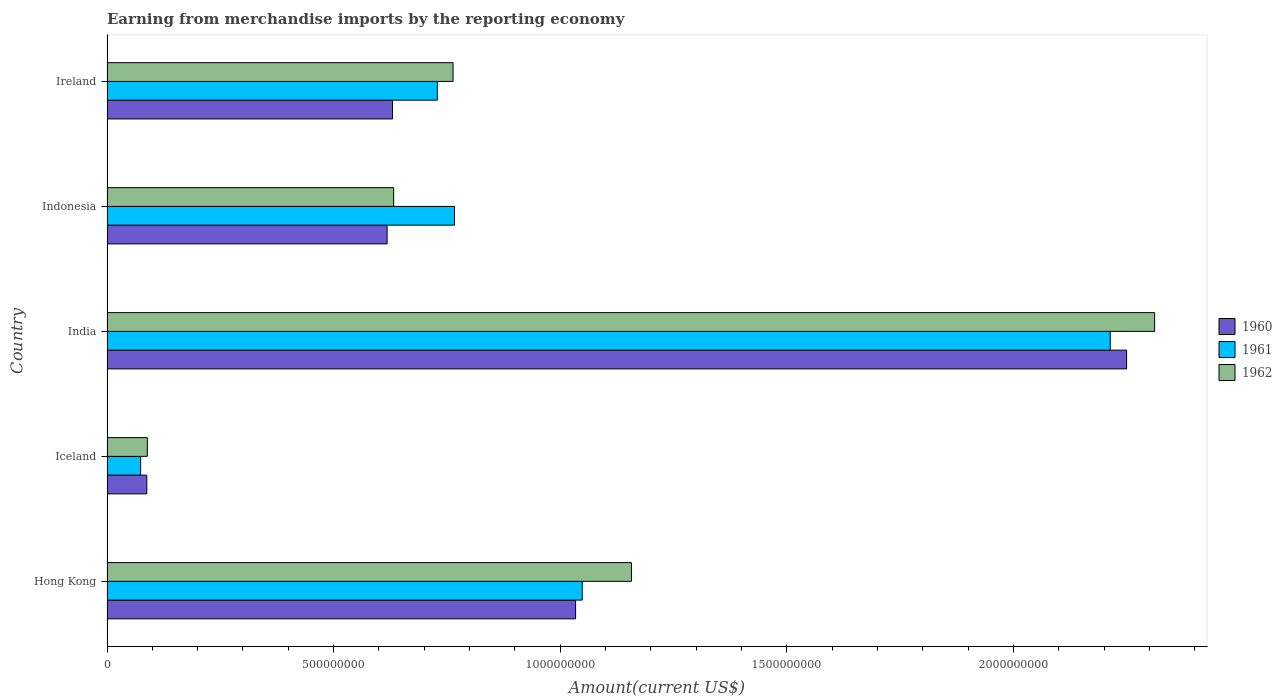How many different coloured bars are there?
Offer a terse response. 3. Are the number of bars per tick equal to the number of legend labels?
Your answer should be very brief. Yes. How many bars are there on the 4th tick from the top?
Give a very brief answer. 3. What is the label of the 4th group of bars from the top?
Keep it short and to the point. Iceland. In how many cases, is the number of bars for a given country not equal to the number of legend labels?
Ensure brevity in your answer.  0. What is the amount earned from merchandise imports in 1960 in Ireland?
Provide a short and direct response. 6.30e+08. Across all countries, what is the maximum amount earned from merchandise imports in 1961?
Offer a very short reply. 2.21e+09. Across all countries, what is the minimum amount earned from merchandise imports in 1961?
Give a very brief answer. 7.42e+07. In which country was the amount earned from merchandise imports in 1961 minimum?
Ensure brevity in your answer.  Iceland. What is the total amount earned from merchandise imports in 1961 in the graph?
Make the answer very short. 4.83e+09. What is the difference between the amount earned from merchandise imports in 1962 in Hong Kong and that in India?
Offer a very short reply. -1.15e+09. What is the difference between the amount earned from merchandise imports in 1961 in Ireland and the amount earned from merchandise imports in 1960 in Indonesia?
Ensure brevity in your answer.  1.11e+08. What is the average amount earned from merchandise imports in 1961 per country?
Your answer should be very brief. 9.66e+08. What is the difference between the amount earned from merchandise imports in 1962 and amount earned from merchandise imports in 1961 in Iceland?
Offer a terse response. 1.48e+07. In how many countries, is the amount earned from merchandise imports in 1960 greater than 1400000000 US$?
Your answer should be very brief. 1. What is the ratio of the amount earned from merchandise imports in 1961 in Hong Kong to that in Ireland?
Make the answer very short. 1.44. Is the amount earned from merchandise imports in 1961 in India less than that in Indonesia?
Provide a succinct answer. No. Is the difference between the amount earned from merchandise imports in 1962 in Hong Kong and India greater than the difference between the amount earned from merchandise imports in 1961 in Hong Kong and India?
Offer a terse response. Yes. What is the difference between the highest and the second highest amount earned from merchandise imports in 1962?
Offer a very short reply. 1.15e+09. What is the difference between the highest and the lowest amount earned from merchandise imports in 1960?
Provide a succinct answer. 2.16e+09. In how many countries, is the amount earned from merchandise imports in 1960 greater than the average amount earned from merchandise imports in 1960 taken over all countries?
Ensure brevity in your answer.  2. Is the sum of the amount earned from merchandise imports in 1962 in Indonesia and Ireland greater than the maximum amount earned from merchandise imports in 1961 across all countries?
Make the answer very short. No. What does the 1st bar from the bottom in Indonesia represents?
Keep it short and to the point. 1960. Is it the case that in every country, the sum of the amount earned from merchandise imports in 1962 and amount earned from merchandise imports in 1961 is greater than the amount earned from merchandise imports in 1960?
Provide a succinct answer. Yes. How many bars are there?
Provide a short and direct response. 15. How many countries are there in the graph?
Provide a succinct answer. 5. Does the graph contain grids?
Offer a terse response. No. What is the title of the graph?
Make the answer very short. Earning from merchandise imports by the reporting economy. What is the label or title of the X-axis?
Your response must be concise. Amount(current US$). What is the label or title of the Y-axis?
Provide a short and direct response. Country. What is the Amount(current US$) in 1960 in Hong Kong?
Make the answer very short. 1.03e+09. What is the Amount(current US$) of 1961 in Hong Kong?
Give a very brief answer. 1.05e+09. What is the Amount(current US$) in 1962 in Hong Kong?
Your response must be concise. 1.16e+09. What is the Amount(current US$) of 1960 in Iceland?
Your response must be concise. 8.78e+07. What is the Amount(current US$) of 1961 in Iceland?
Provide a succinct answer. 7.42e+07. What is the Amount(current US$) in 1962 in Iceland?
Ensure brevity in your answer.  8.90e+07. What is the Amount(current US$) of 1960 in India?
Your answer should be compact. 2.25e+09. What is the Amount(current US$) in 1961 in India?
Offer a very short reply. 2.21e+09. What is the Amount(current US$) of 1962 in India?
Your answer should be compact. 2.31e+09. What is the Amount(current US$) of 1960 in Indonesia?
Provide a short and direct response. 6.18e+08. What is the Amount(current US$) of 1961 in Indonesia?
Provide a succinct answer. 7.67e+08. What is the Amount(current US$) of 1962 in Indonesia?
Offer a very short reply. 6.32e+08. What is the Amount(current US$) of 1960 in Ireland?
Give a very brief answer. 6.30e+08. What is the Amount(current US$) in 1961 in Ireland?
Offer a very short reply. 7.29e+08. What is the Amount(current US$) of 1962 in Ireland?
Your answer should be compact. 7.64e+08. Across all countries, what is the maximum Amount(current US$) in 1960?
Offer a terse response. 2.25e+09. Across all countries, what is the maximum Amount(current US$) of 1961?
Offer a very short reply. 2.21e+09. Across all countries, what is the maximum Amount(current US$) of 1962?
Offer a very short reply. 2.31e+09. Across all countries, what is the minimum Amount(current US$) in 1960?
Offer a very short reply. 8.78e+07. Across all countries, what is the minimum Amount(current US$) in 1961?
Provide a short and direct response. 7.42e+07. Across all countries, what is the minimum Amount(current US$) of 1962?
Provide a succinct answer. 8.90e+07. What is the total Amount(current US$) of 1960 in the graph?
Provide a short and direct response. 4.62e+09. What is the total Amount(current US$) of 1961 in the graph?
Make the answer very short. 4.83e+09. What is the total Amount(current US$) of 1962 in the graph?
Your answer should be very brief. 4.95e+09. What is the difference between the Amount(current US$) of 1960 in Hong Kong and that in Iceland?
Provide a succinct answer. 9.46e+08. What is the difference between the Amount(current US$) in 1961 in Hong Kong and that in Iceland?
Offer a very short reply. 9.74e+08. What is the difference between the Amount(current US$) in 1962 in Hong Kong and that in Iceland?
Offer a terse response. 1.07e+09. What is the difference between the Amount(current US$) of 1960 in Hong Kong and that in India?
Make the answer very short. -1.22e+09. What is the difference between the Amount(current US$) in 1961 in Hong Kong and that in India?
Make the answer very short. -1.16e+09. What is the difference between the Amount(current US$) of 1962 in Hong Kong and that in India?
Keep it short and to the point. -1.15e+09. What is the difference between the Amount(current US$) in 1960 in Hong Kong and that in Indonesia?
Make the answer very short. 4.16e+08. What is the difference between the Amount(current US$) of 1961 in Hong Kong and that in Indonesia?
Provide a short and direct response. 2.82e+08. What is the difference between the Amount(current US$) in 1962 in Hong Kong and that in Indonesia?
Offer a very short reply. 5.25e+08. What is the difference between the Amount(current US$) of 1960 in Hong Kong and that in Ireland?
Offer a terse response. 4.04e+08. What is the difference between the Amount(current US$) of 1961 in Hong Kong and that in Ireland?
Offer a terse response. 3.20e+08. What is the difference between the Amount(current US$) in 1962 in Hong Kong and that in Ireland?
Offer a terse response. 3.94e+08. What is the difference between the Amount(current US$) of 1960 in Iceland and that in India?
Your response must be concise. -2.16e+09. What is the difference between the Amount(current US$) in 1961 in Iceland and that in India?
Offer a very short reply. -2.14e+09. What is the difference between the Amount(current US$) of 1962 in Iceland and that in India?
Your answer should be compact. -2.22e+09. What is the difference between the Amount(current US$) of 1960 in Iceland and that in Indonesia?
Your response must be concise. -5.30e+08. What is the difference between the Amount(current US$) of 1961 in Iceland and that in Indonesia?
Provide a succinct answer. -6.92e+08. What is the difference between the Amount(current US$) in 1962 in Iceland and that in Indonesia?
Your answer should be compact. -5.43e+08. What is the difference between the Amount(current US$) of 1960 in Iceland and that in Ireland?
Ensure brevity in your answer.  -5.42e+08. What is the difference between the Amount(current US$) of 1961 in Iceland and that in Ireland?
Make the answer very short. -6.55e+08. What is the difference between the Amount(current US$) in 1962 in Iceland and that in Ireland?
Offer a terse response. -6.74e+08. What is the difference between the Amount(current US$) in 1960 in India and that in Indonesia?
Give a very brief answer. 1.63e+09. What is the difference between the Amount(current US$) of 1961 in India and that in Indonesia?
Offer a very short reply. 1.45e+09. What is the difference between the Amount(current US$) in 1962 in India and that in Indonesia?
Keep it short and to the point. 1.68e+09. What is the difference between the Amount(current US$) in 1960 in India and that in Ireland?
Make the answer very short. 1.62e+09. What is the difference between the Amount(current US$) of 1961 in India and that in Ireland?
Your answer should be compact. 1.48e+09. What is the difference between the Amount(current US$) of 1962 in India and that in Ireland?
Ensure brevity in your answer.  1.55e+09. What is the difference between the Amount(current US$) in 1960 in Indonesia and that in Ireland?
Ensure brevity in your answer.  -1.19e+07. What is the difference between the Amount(current US$) of 1961 in Indonesia and that in Ireland?
Make the answer very short. 3.78e+07. What is the difference between the Amount(current US$) in 1962 in Indonesia and that in Ireland?
Keep it short and to the point. -1.31e+08. What is the difference between the Amount(current US$) in 1960 in Hong Kong and the Amount(current US$) in 1961 in Iceland?
Your answer should be compact. 9.60e+08. What is the difference between the Amount(current US$) of 1960 in Hong Kong and the Amount(current US$) of 1962 in Iceland?
Make the answer very short. 9.45e+08. What is the difference between the Amount(current US$) in 1961 in Hong Kong and the Amount(current US$) in 1962 in Iceland?
Provide a short and direct response. 9.59e+08. What is the difference between the Amount(current US$) in 1960 in Hong Kong and the Amount(current US$) in 1961 in India?
Make the answer very short. -1.18e+09. What is the difference between the Amount(current US$) in 1960 in Hong Kong and the Amount(current US$) in 1962 in India?
Offer a terse response. -1.28e+09. What is the difference between the Amount(current US$) of 1961 in Hong Kong and the Amount(current US$) of 1962 in India?
Offer a terse response. -1.26e+09. What is the difference between the Amount(current US$) in 1960 in Hong Kong and the Amount(current US$) in 1961 in Indonesia?
Your answer should be compact. 2.67e+08. What is the difference between the Amount(current US$) of 1960 in Hong Kong and the Amount(current US$) of 1962 in Indonesia?
Your response must be concise. 4.01e+08. What is the difference between the Amount(current US$) of 1961 in Hong Kong and the Amount(current US$) of 1962 in Indonesia?
Ensure brevity in your answer.  4.16e+08. What is the difference between the Amount(current US$) of 1960 in Hong Kong and the Amount(current US$) of 1961 in Ireland?
Make the answer very short. 3.05e+08. What is the difference between the Amount(current US$) in 1960 in Hong Kong and the Amount(current US$) in 1962 in Ireland?
Offer a very short reply. 2.70e+08. What is the difference between the Amount(current US$) of 1961 in Hong Kong and the Amount(current US$) of 1962 in Ireland?
Ensure brevity in your answer.  2.85e+08. What is the difference between the Amount(current US$) in 1960 in Iceland and the Amount(current US$) in 1961 in India?
Give a very brief answer. -2.13e+09. What is the difference between the Amount(current US$) in 1960 in Iceland and the Amount(current US$) in 1962 in India?
Provide a succinct answer. -2.22e+09. What is the difference between the Amount(current US$) of 1961 in Iceland and the Amount(current US$) of 1962 in India?
Your response must be concise. -2.24e+09. What is the difference between the Amount(current US$) in 1960 in Iceland and the Amount(current US$) in 1961 in Indonesia?
Offer a terse response. -6.79e+08. What is the difference between the Amount(current US$) in 1960 in Iceland and the Amount(current US$) in 1962 in Indonesia?
Offer a very short reply. -5.45e+08. What is the difference between the Amount(current US$) in 1961 in Iceland and the Amount(current US$) in 1962 in Indonesia?
Your answer should be compact. -5.58e+08. What is the difference between the Amount(current US$) of 1960 in Iceland and the Amount(current US$) of 1961 in Ireland?
Provide a succinct answer. -6.41e+08. What is the difference between the Amount(current US$) of 1960 in Iceland and the Amount(current US$) of 1962 in Ireland?
Give a very brief answer. -6.76e+08. What is the difference between the Amount(current US$) in 1961 in Iceland and the Amount(current US$) in 1962 in Ireland?
Keep it short and to the point. -6.89e+08. What is the difference between the Amount(current US$) of 1960 in India and the Amount(current US$) of 1961 in Indonesia?
Ensure brevity in your answer.  1.48e+09. What is the difference between the Amount(current US$) of 1960 in India and the Amount(current US$) of 1962 in Indonesia?
Provide a succinct answer. 1.62e+09. What is the difference between the Amount(current US$) of 1961 in India and the Amount(current US$) of 1962 in Indonesia?
Keep it short and to the point. 1.58e+09. What is the difference between the Amount(current US$) in 1960 in India and the Amount(current US$) in 1961 in Ireland?
Provide a short and direct response. 1.52e+09. What is the difference between the Amount(current US$) of 1960 in India and the Amount(current US$) of 1962 in Ireland?
Make the answer very short. 1.49e+09. What is the difference between the Amount(current US$) in 1961 in India and the Amount(current US$) in 1962 in Ireland?
Your response must be concise. 1.45e+09. What is the difference between the Amount(current US$) in 1960 in Indonesia and the Amount(current US$) in 1961 in Ireland?
Your answer should be compact. -1.11e+08. What is the difference between the Amount(current US$) of 1960 in Indonesia and the Amount(current US$) of 1962 in Ireland?
Keep it short and to the point. -1.46e+08. What is the difference between the Amount(current US$) in 1961 in Indonesia and the Amount(current US$) in 1962 in Ireland?
Make the answer very short. 3.10e+06. What is the average Amount(current US$) of 1960 per country?
Make the answer very short. 9.24e+08. What is the average Amount(current US$) of 1961 per country?
Keep it short and to the point. 9.66e+08. What is the average Amount(current US$) in 1962 per country?
Keep it short and to the point. 9.91e+08. What is the difference between the Amount(current US$) in 1960 and Amount(current US$) in 1961 in Hong Kong?
Provide a succinct answer. -1.46e+07. What is the difference between the Amount(current US$) in 1960 and Amount(current US$) in 1962 in Hong Kong?
Provide a succinct answer. -1.23e+08. What is the difference between the Amount(current US$) in 1961 and Amount(current US$) in 1962 in Hong Kong?
Your answer should be compact. -1.09e+08. What is the difference between the Amount(current US$) of 1960 and Amount(current US$) of 1961 in Iceland?
Provide a short and direct response. 1.36e+07. What is the difference between the Amount(current US$) in 1960 and Amount(current US$) in 1962 in Iceland?
Your response must be concise. -1.20e+06. What is the difference between the Amount(current US$) in 1961 and Amount(current US$) in 1962 in Iceland?
Make the answer very short. -1.48e+07. What is the difference between the Amount(current US$) in 1960 and Amount(current US$) in 1961 in India?
Your answer should be very brief. 3.61e+07. What is the difference between the Amount(current US$) of 1960 and Amount(current US$) of 1962 in India?
Offer a terse response. -6.18e+07. What is the difference between the Amount(current US$) in 1961 and Amount(current US$) in 1962 in India?
Provide a short and direct response. -9.79e+07. What is the difference between the Amount(current US$) in 1960 and Amount(current US$) in 1961 in Indonesia?
Offer a very short reply. -1.49e+08. What is the difference between the Amount(current US$) of 1960 and Amount(current US$) of 1962 in Indonesia?
Provide a short and direct response. -1.44e+07. What is the difference between the Amount(current US$) of 1961 and Amount(current US$) of 1962 in Indonesia?
Provide a succinct answer. 1.34e+08. What is the difference between the Amount(current US$) in 1960 and Amount(current US$) in 1961 in Ireland?
Your answer should be very brief. -9.89e+07. What is the difference between the Amount(current US$) of 1960 and Amount(current US$) of 1962 in Ireland?
Make the answer very short. -1.34e+08. What is the difference between the Amount(current US$) of 1961 and Amount(current US$) of 1962 in Ireland?
Give a very brief answer. -3.47e+07. What is the ratio of the Amount(current US$) in 1960 in Hong Kong to that in Iceland?
Your answer should be compact. 11.77. What is the ratio of the Amount(current US$) of 1961 in Hong Kong to that in Iceland?
Your response must be concise. 14.13. What is the ratio of the Amount(current US$) in 1962 in Hong Kong to that in Iceland?
Your answer should be very brief. 13. What is the ratio of the Amount(current US$) in 1960 in Hong Kong to that in India?
Offer a very short reply. 0.46. What is the ratio of the Amount(current US$) of 1961 in Hong Kong to that in India?
Offer a terse response. 0.47. What is the ratio of the Amount(current US$) in 1962 in Hong Kong to that in India?
Make the answer very short. 0.5. What is the ratio of the Amount(current US$) in 1960 in Hong Kong to that in Indonesia?
Your response must be concise. 1.67. What is the ratio of the Amount(current US$) of 1961 in Hong Kong to that in Indonesia?
Offer a terse response. 1.37. What is the ratio of the Amount(current US$) in 1962 in Hong Kong to that in Indonesia?
Your answer should be very brief. 1.83. What is the ratio of the Amount(current US$) in 1960 in Hong Kong to that in Ireland?
Offer a very short reply. 1.64. What is the ratio of the Amount(current US$) of 1961 in Hong Kong to that in Ireland?
Your response must be concise. 1.44. What is the ratio of the Amount(current US$) in 1962 in Hong Kong to that in Ireland?
Give a very brief answer. 1.52. What is the ratio of the Amount(current US$) of 1960 in Iceland to that in India?
Provide a short and direct response. 0.04. What is the ratio of the Amount(current US$) in 1961 in Iceland to that in India?
Ensure brevity in your answer.  0.03. What is the ratio of the Amount(current US$) of 1962 in Iceland to that in India?
Give a very brief answer. 0.04. What is the ratio of the Amount(current US$) of 1960 in Iceland to that in Indonesia?
Provide a short and direct response. 0.14. What is the ratio of the Amount(current US$) of 1961 in Iceland to that in Indonesia?
Provide a succinct answer. 0.1. What is the ratio of the Amount(current US$) in 1962 in Iceland to that in Indonesia?
Your answer should be compact. 0.14. What is the ratio of the Amount(current US$) in 1960 in Iceland to that in Ireland?
Your answer should be compact. 0.14. What is the ratio of the Amount(current US$) of 1961 in Iceland to that in Ireland?
Ensure brevity in your answer.  0.1. What is the ratio of the Amount(current US$) in 1962 in Iceland to that in Ireland?
Your answer should be compact. 0.12. What is the ratio of the Amount(current US$) of 1960 in India to that in Indonesia?
Ensure brevity in your answer.  3.64. What is the ratio of the Amount(current US$) of 1961 in India to that in Indonesia?
Keep it short and to the point. 2.89. What is the ratio of the Amount(current US$) of 1962 in India to that in Indonesia?
Keep it short and to the point. 3.65. What is the ratio of the Amount(current US$) in 1960 in India to that in Ireland?
Ensure brevity in your answer.  3.57. What is the ratio of the Amount(current US$) of 1961 in India to that in Ireland?
Provide a succinct answer. 3.04. What is the ratio of the Amount(current US$) in 1962 in India to that in Ireland?
Ensure brevity in your answer.  3.03. What is the ratio of the Amount(current US$) in 1960 in Indonesia to that in Ireland?
Ensure brevity in your answer.  0.98. What is the ratio of the Amount(current US$) in 1961 in Indonesia to that in Ireland?
Your answer should be compact. 1.05. What is the ratio of the Amount(current US$) in 1962 in Indonesia to that in Ireland?
Give a very brief answer. 0.83. What is the difference between the highest and the second highest Amount(current US$) of 1960?
Keep it short and to the point. 1.22e+09. What is the difference between the highest and the second highest Amount(current US$) of 1961?
Give a very brief answer. 1.16e+09. What is the difference between the highest and the second highest Amount(current US$) of 1962?
Provide a succinct answer. 1.15e+09. What is the difference between the highest and the lowest Amount(current US$) of 1960?
Your response must be concise. 2.16e+09. What is the difference between the highest and the lowest Amount(current US$) of 1961?
Give a very brief answer. 2.14e+09. What is the difference between the highest and the lowest Amount(current US$) of 1962?
Your response must be concise. 2.22e+09. 